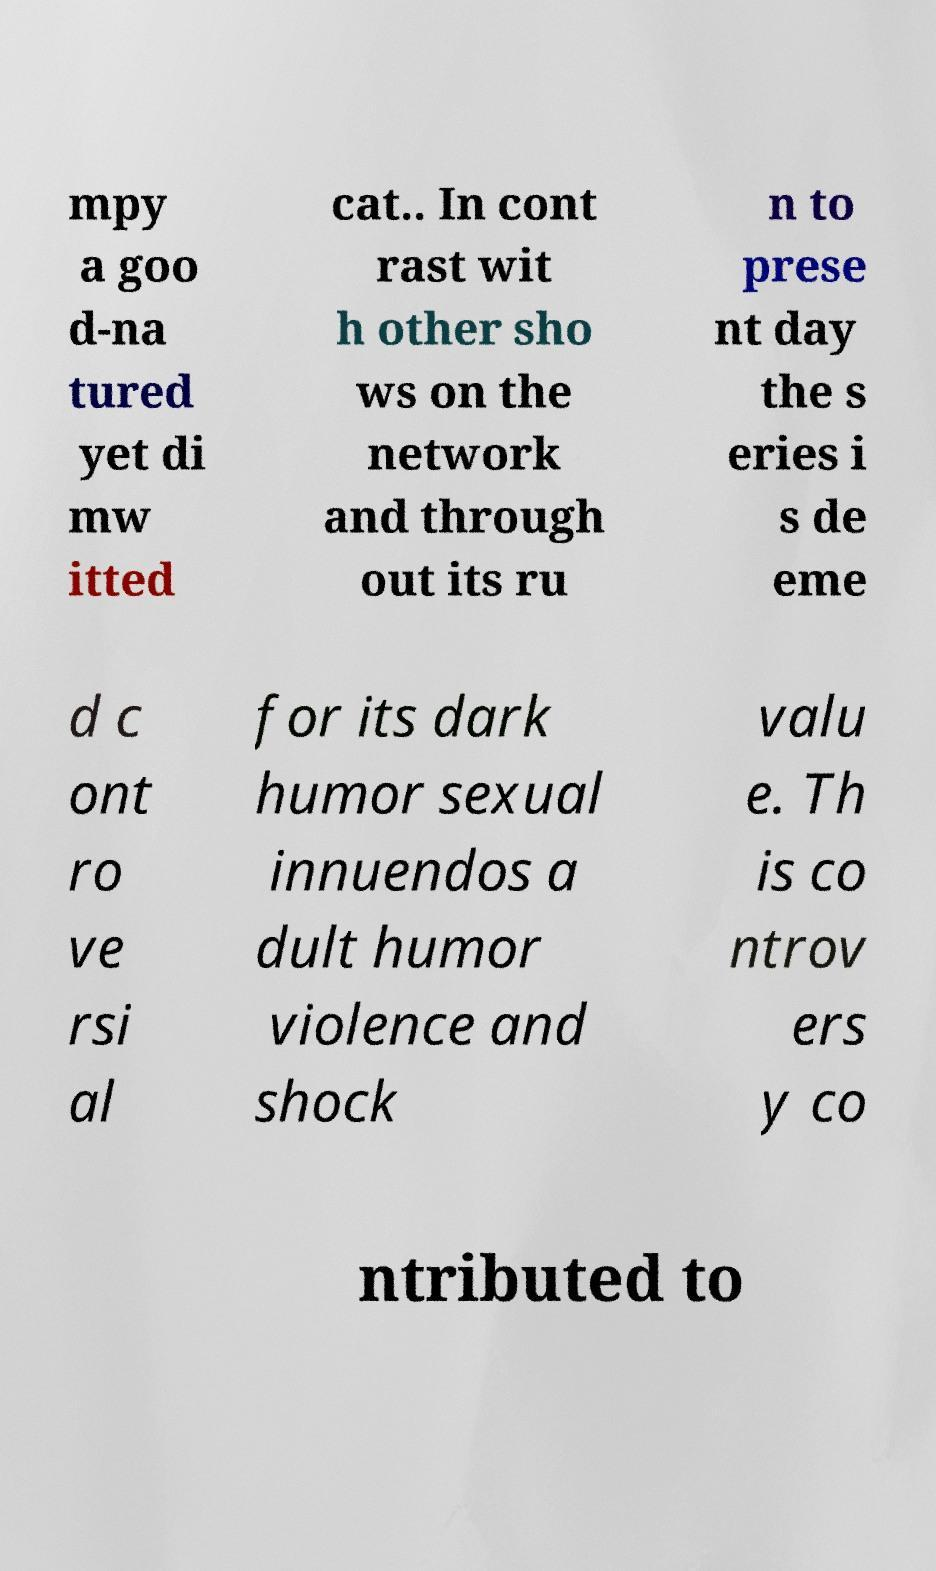Could you assist in decoding the text presented in this image and type it out clearly? mpy a goo d-na tured yet di mw itted cat.. In cont rast wit h other sho ws on the network and through out its ru n to prese nt day the s eries i s de eme d c ont ro ve rsi al for its dark humor sexual innuendos a dult humor violence and shock valu e. Th is co ntrov ers y co ntributed to 